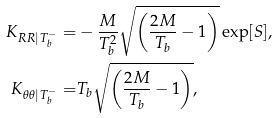<formula> <loc_0><loc_0><loc_500><loc_500>K _ { R R | T _ { b } ^ { - } } = & - \frac { M } { T _ { b } ^ { 2 } } \sqrt { \left ( \frac { 2 M } { T _ { b } } - 1 \right ) } \exp [ S ] , \\ K _ { \theta \theta | T _ { b } ^ { - } } = & T _ { b } \sqrt { \left ( \frac { 2 M } { T _ { b } } - 1 \right ) } ,</formula> 